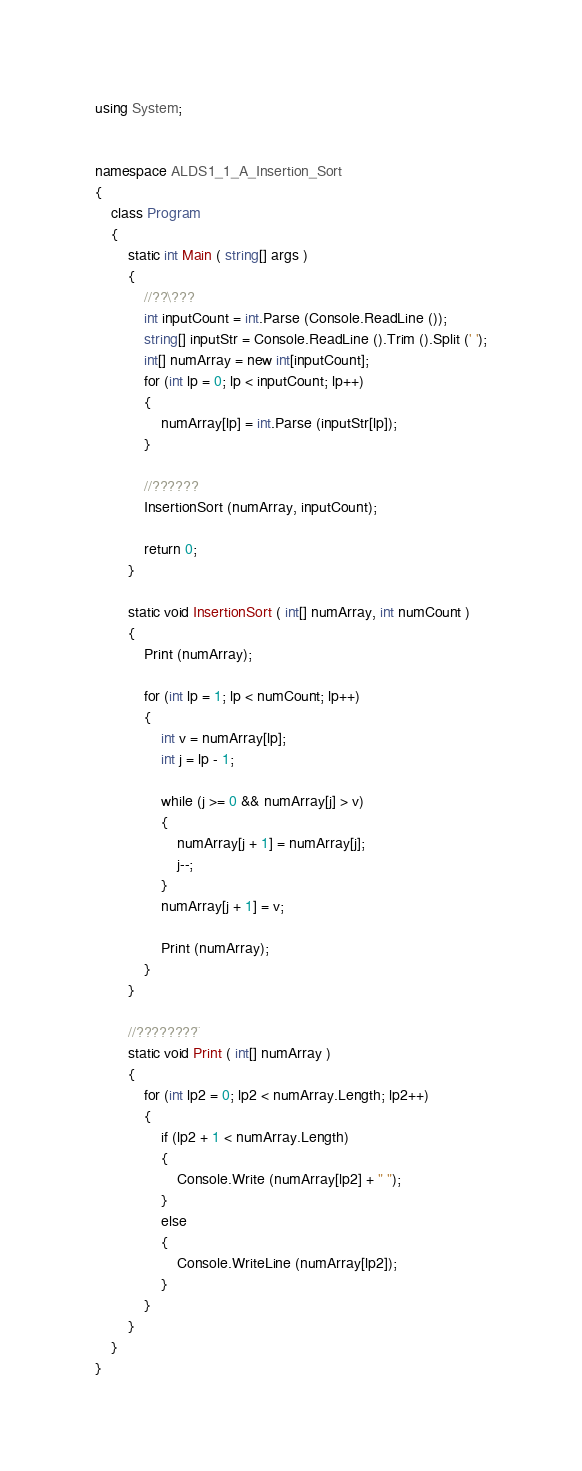Convert code to text. <code><loc_0><loc_0><loc_500><loc_500><_C#_>using System;


namespace ALDS1_1_A_Insertion_Sort
{
	class Program
	{
		static int Main ( string[] args )
		{
			//??\???
			int inputCount = int.Parse (Console.ReadLine ());
			string[] inputStr = Console.ReadLine ().Trim ().Split (' ');
			int[] numArray = new int[inputCount];
			for (int lp = 0; lp < inputCount; lp++)
			{
				numArray[lp] = int.Parse (inputStr[lp]);
			}

			//??????
			InsertionSort (numArray, inputCount);

			return 0;
		}

		static void InsertionSort ( int[] numArray, int numCount )
		{
			Print (numArray);

			for (int lp = 1; lp < numCount; lp++)
			{
				int v = numArray[lp];
				int j = lp - 1;

				while (j >= 0 && numArray[j] > v)
				{
					numArray[j + 1] = numArray[j];
					j--;
				}
				numArray[j + 1] = v;

				Print (numArray);
			}
		}

		//????????¨
		static void Print ( int[] numArray )
		{
			for (int lp2 = 0; lp2 < numArray.Length; lp2++)
			{
				if (lp2 + 1 < numArray.Length)
				{
					Console.Write (numArray[lp2] + " ");
				}
				else
				{
					Console.WriteLine (numArray[lp2]);
				}
			}
		}
	}
}</code> 